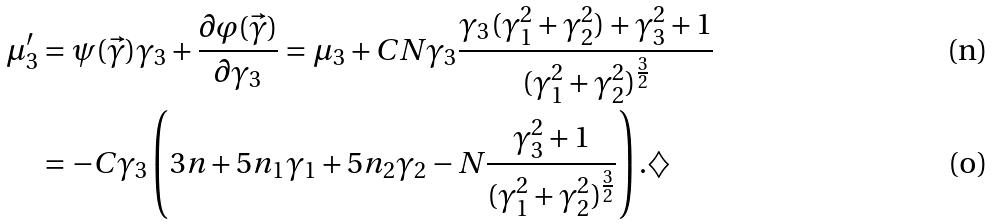Convert formula to latex. <formula><loc_0><loc_0><loc_500><loc_500>\mu _ { 3 } ^ { \prime } & = \psi ( \vec { \gamma } ) \gamma _ { 3 } + \frac { \partial \varphi ( \vec { \gamma } ) } { \partial \gamma _ { 3 } } = \mu _ { 3 } + C N \gamma _ { 3 } \frac { \gamma _ { 3 } ( \gamma _ { 1 } ^ { 2 } + \gamma _ { 2 } ^ { 2 } ) + \gamma _ { 3 } ^ { 2 } + 1 } { ( \gamma _ { 1 } ^ { 2 } + \gamma _ { 2 } ^ { 2 } ) ^ { \frac { 3 } { 2 } } } \\ & = - C \gamma _ { 3 } \left ( 3 n + 5 n _ { 1 } \gamma _ { 1 } + 5 n _ { 2 } \gamma _ { 2 } - N \frac { \gamma _ { 3 } ^ { 2 } + 1 } { ( \gamma _ { 1 } ^ { 2 } + \gamma _ { 2 } ^ { 2 } ) ^ { \frac { 3 } { 2 } } } \right ) . \diamondsuit</formula> 